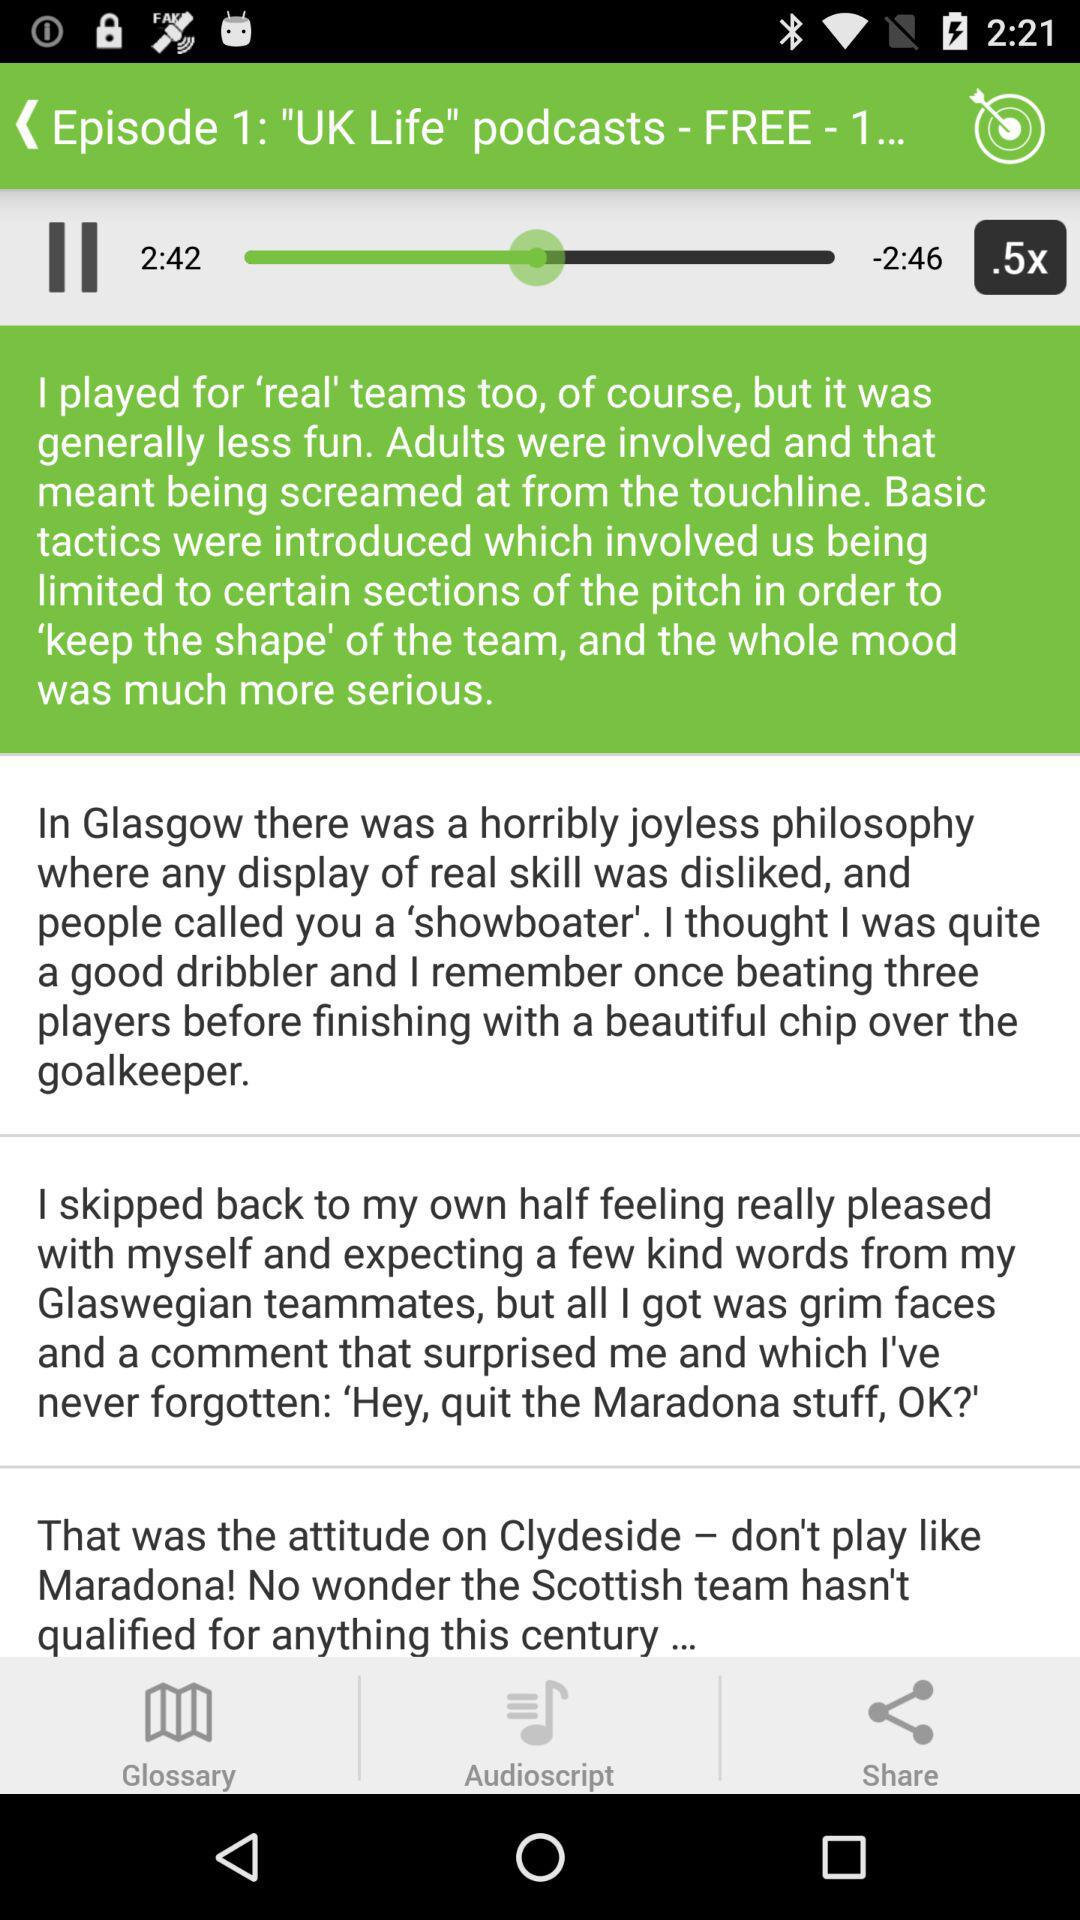What is the average length? The average length is 3 minutes. 